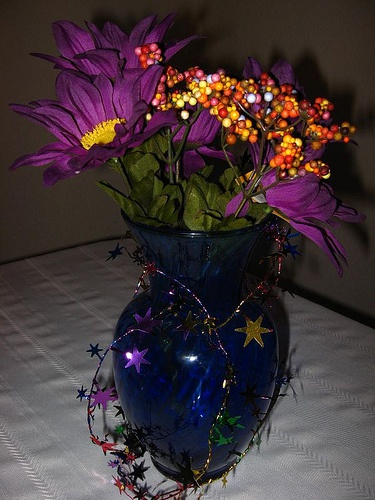Describe the objects in this image and their specific colors. I can see dining table in black and gray tones and vase in black, navy, gray, and olive tones in this image. 